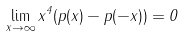Convert formula to latex. <formula><loc_0><loc_0><loc_500><loc_500>\lim _ { x \to \infty } x ^ { 4 } ( p ( x ) - p ( - x ) ) = 0</formula> 